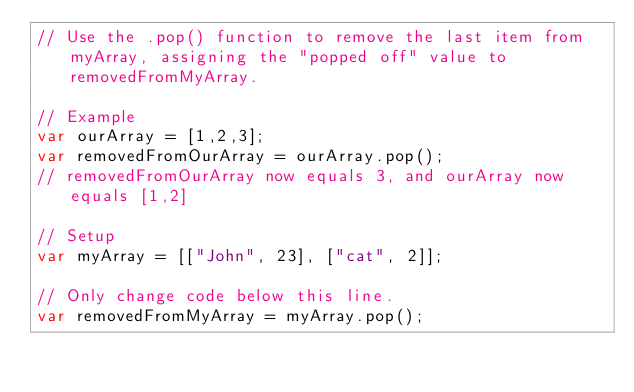<code> <loc_0><loc_0><loc_500><loc_500><_JavaScript_>// Use the .pop() function to remove the last item from myArray, assigning the "popped off" value to removedFromMyArray.

// Example
var ourArray = [1,2,3];
var removedFromOurArray = ourArray.pop();
// removedFromOurArray now equals 3, and ourArray now equals [1,2]

// Setup
var myArray = [["John", 23], ["cat", 2]];

// Only change code below this line.
var removedFromMyArray = myArray.pop();


</code> 